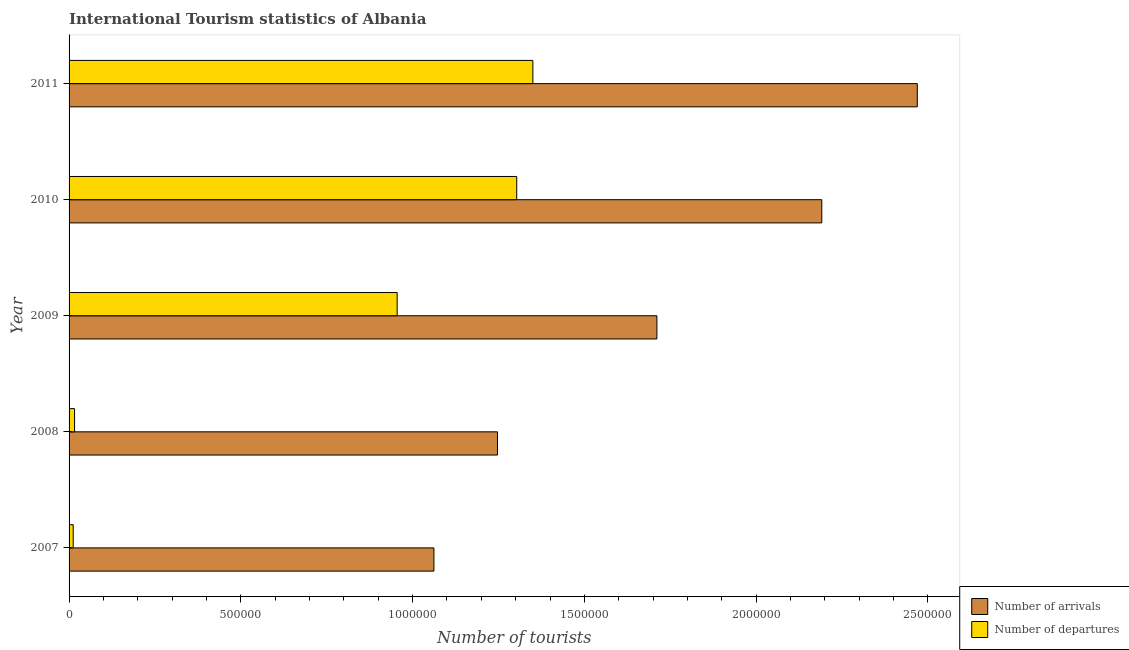How many bars are there on the 5th tick from the top?
Keep it short and to the point. 2. How many bars are there on the 4th tick from the bottom?
Offer a terse response. 2. What is the label of the 5th group of bars from the top?
Your response must be concise. 2007. In how many cases, is the number of bars for a given year not equal to the number of legend labels?
Your answer should be very brief. 0. What is the number of tourist arrivals in 2007?
Ensure brevity in your answer.  1.06e+06. Across all years, what is the maximum number of tourist departures?
Provide a short and direct response. 1.35e+06. Across all years, what is the minimum number of tourist departures?
Offer a very short reply. 1.20e+04. In which year was the number of tourist departures maximum?
Offer a very short reply. 2011. What is the total number of tourist departures in the graph?
Your answer should be compact. 3.64e+06. What is the difference between the number of tourist arrivals in 2009 and that in 2010?
Keep it short and to the point. -4.80e+05. What is the difference between the number of tourist arrivals in 2009 and the number of tourist departures in 2011?
Your answer should be very brief. 3.61e+05. What is the average number of tourist departures per year?
Ensure brevity in your answer.  7.27e+05. In the year 2010, what is the difference between the number of tourist departures and number of tourist arrivals?
Your answer should be very brief. -8.88e+05. What is the ratio of the number of tourist departures in 2009 to that in 2011?
Offer a very short reply. 0.71. Is the number of tourist arrivals in 2008 less than that in 2010?
Provide a succinct answer. Yes. What is the difference between the highest and the second highest number of tourist departures?
Your response must be concise. 4.70e+04. What is the difference between the highest and the lowest number of tourist arrivals?
Ensure brevity in your answer.  1.41e+06. In how many years, is the number of tourist departures greater than the average number of tourist departures taken over all years?
Your answer should be compact. 3. What does the 1st bar from the top in 2011 represents?
Offer a terse response. Number of departures. What does the 1st bar from the bottom in 2009 represents?
Ensure brevity in your answer.  Number of arrivals. How many bars are there?
Offer a very short reply. 10. How many years are there in the graph?
Your response must be concise. 5. What is the difference between two consecutive major ticks on the X-axis?
Make the answer very short. 5.00e+05. Does the graph contain any zero values?
Provide a short and direct response. No. What is the title of the graph?
Your answer should be very brief. International Tourism statistics of Albania. What is the label or title of the X-axis?
Your answer should be compact. Number of tourists. What is the label or title of the Y-axis?
Provide a succinct answer. Year. What is the Number of tourists in Number of arrivals in 2007?
Provide a succinct answer. 1.06e+06. What is the Number of tourists of Number of departures in 2007?
Provide a short and direct response. 1.20e+04. What is the Number of tourists of Number of arrivals in 2008?
Keep it short and to the point. 1.25e+06. What is the Number of tourists of Number of departures in 2008?
Offer a terse response. 1.60e+04. What is the Number of tourists of Number of arrivals in 2009?
Provide a succinct answer. 1.71e+06. What is the Number of tourists of Number of departures in 2009?
Provide a succinct answer. 9.55e+05. What is the Number of tourists in Number of arrivals in 2010?
Provide a succinct answer. 2.19e+06. What is the Number of tourists in Number of departures in 2010?
Keep it short and to the point. 1.30e+06. What is the Number of tourists of Number of arrivals in 2011?
Your answer should be compact. 2.47e+06. What is the Number of tourists of Number of departures in 2011?
Make the answer very short. 1.35e+06. Across all years, what is the maximum Number of tourists in Number of arrivals?
Offer a very short reply. 2.47e+06. Across all years, what is the maximum Number of tourists of Number of departures?
Provide a short and direct response. 1.35e+06. Across all years, what is the minimum Number of tourists in Number of arrivals?
Give a very brief answer. 1.06e+06. Across all years, what is the minimum Number of tourists in Number of departures?
Provide a succinct answer. 1.20e+04. What is the total Number of tourists in Number of arrivals in the graph?
Keep it short and to the point. 8.68e+06. What is the total Number of tourists in Number of departures in the graph?
Make the answer very short. 3.64e+06. What is the difference between the Number of tourists in Number of arrivals in 2007 and that in 2008?
Your answer should be compact. -1.85e+05. What is the difference between the Number of tourists in Number of departures in 2007 and that in 2008?
Offer a very short reply. -4000. What is the difference between the Number of tourists of Number of arrivals in 2007 and that in 2009?
Your answer should be compact. -6.49e+05. What is the difference between the Number of tourists of Number of departures in 2007 and that in 2009?
Provide a succinct answer. -9.43e+05. What is the difference between the Number of tourists of Number of arrivals in 2007 and that in 2010?
Your answer should be compact. -1.13e+06. What is the difference between the Number of tourists in Number of departures in 2007 and that in 2010?
Your answer should be compact. -1.29e+06. What is the difference between the Number of tourists of Number of arrivals in 2007 and that in 2011?
Your answer should be compact. -1.41e+06. What is the difference between the Number of tourists of Number of departures in 2007 and that in 2011?
Provide a succinct answer. -1.34e+06. What is the difference between the Number of tourists of Number of arrivals in 2008 and that in 2009?
Your answer should be very brief. -4.64e+05. What is the difference between the Number of tourists of Number of departures in 2008 and that in 2009?
Make the answer very short. -9.39e+05. What is the difference between the Number of tourists of Number of arrivals in 2008 and that in 2010?
Give a very brief answer. -9.44e+05. What is the difference between the Number of tourists in Number of departures in 2008 and that in 2010?
Offer a very short reply. -1.29e+06. What is the difference between the Number of tourists of Number of arrivals in 2008 and that in 2011?
Your answer should be very brief. -1.22e+06. What is the difference between the Number of tourists in Number of departures in 2008 and that in 2011?
Offer a terse response. -1.33e+06. What is the difference between the Number of tourists of Number of arrivals in 2009 and that in 2010?
Your answer should be very brief. -4.80e+05. What is the difference between the Number of tourists in Number of departures in 2009 and that in 2010?
Offer a very short reply. -3.48e+05. What is the difference between the Number of tourists in Number of arrivals in 2009 and that in 2011?
Make the answer very short. -7.58e+05. What is the difference between the Number of tourists of Number of departures in 2009 and that in 2011?
Give a very brief answer. -3.95e+05. What is the difference between the Number of tourists in Number of arrivals in 2010 and that in 2011?
Your answer should be very brief. -2.78e+05. What is the difference between the Number of tourists of Number of departures in 2010 and that in 2011?
Offer a terse response. -4.70e+04. What is the difference between the Number of tourists of Number of arrivals in 2007 and the Number of tourists of Number of departures in 2008?
Offer a terse response. 1.05e+06. What is the difference between the Number of tourists of Number of arrivals in 2007 and the Number of tourists of Number of departures in 2009?
Your answer should be very brief. 1.07e+05. What is the difference between the Number of tourists in Number of arrivals in 2007 and the Number of tourists in Number of departures in 2010?
Offer a very short reply. -2.41e+05. What is the difference between the Number of tourists of Number of arrivals in 2007 and the Number of tourists of Number of departures in 2011?
Ensure brevity in your answer.  -2.88e+05. What is the difference between the Number of tourists in Number of arrivals in 2008 and the Number of tourists in Number of departures in 2009?
Ensure brevity in your answer.  2.92e+05. What is the difference between the Number of tourists of Number of arrivals in 2008 and the Number of tourists of Number of departures in 2010?
Keep it short and to the point. -5.60e+04. What is the difference between the Number of tourists in Number of arrivals in 2008 and the Number of tourists in Number of departures in 2011?
Give a very brief answer. -1.03e+05. What is the difference between the Number of tourists in Number of arrivals in 2009 and the Number of tourists in Number of departures in 2010?
Your answer should be very brief. 4.08e+05. What is the difference between the Number of tourists in Number of arrivals in 2009 and the Number of tourists in Number of departures in 2011?
Provide a succinct answer. 3.61e+05. What is the difference between the Number of tourists of Number of arrivals in 2010 and the Number of tourists of Number of departures in 2011?
Offer a very short reply. 8.41e+05. What is the average Number of tourists of Number of arrivals per year?
Your answer should be compact. 1.74e+06. What is the average Number of tourists of Number of departures per year?
Your answer should be compact. 7.27e+05. In the year 2007, what is the difference between the Number of tourists in Number of arrivals and Number of tourists in Number of departures?
Keep it short and to the point. 1.05e+06. In the year 2008, what is the difference between the Number of tourists in Number of arrivals and Number of tourists in Number of departures?
Provide a succinct answer. 1.23e+06. In the year 2009, what is the difference between the Number of tourists of Number of arrivals and Number of tourists of Number of departures?
Your answer should be compact. 7.56e+05. In the year 2010, what is the difference between the Number of tourists of Number of arrivals and Number of tourists of Number of departures?
Ensure brevity in your answer.  8.88e+05. In the year 2011, what is the difference between the Number of tourists in Number of arrivals and Number of tourists in Number of departures?
Ensure brevity in your answer.  1.12e+06. What is the ratio of the Number of tourists in Number of arrivals in 2007 to that in 2008?
Your answer should be very brief. 0.85. What is the ratio of the Number of tourists of Number of departures in 2007 to that in 2008?
Ensure brevity in your answer.  0.75. What is the ratio of the Number of tourists of Number of arrivals in 2007 to that in 2009?
Your answer should be compact. 0.62. What is the ratio of the Number of tourists in Number of departures in 2007 to that in 2009?
Your response must be concise. 0.01. What is the ratio of the Number of tourists of Number of arrivals in 2007 to that in 2010?
Ensure brevity in your answer.  0.48. What is the ratio of the Number of tourists of Number of departures in 2007 to that in 2010?
Your answer should be compact. 0.01. What is the ratio of the Number of tourists in Number of arrivals in 2007 to that in 2011?
Offer a terse response. 0.43. What is the ratio of the Number of tourists of Number of departures in 2007 to that in 2011?
Your answer should be very brief. 0.01. What is the ratio of the Number of tourists in Number of arrivals in 2008 to that in 2009?
Provide a short and direct response. 0.73. What is the ratio of the Number of tourists of Number of departures in 2008 to that in 2009?
Your response must be concise. 0.02. What is the ratio of the Number of tourists of Number of arrivals in 2008 to that in 2010?
Provide a succinct answer. 0.57. What is the ratio of the Number of tourists of Number of departures in 2008 to that in 2010?
Make the answer very short. 0.01. What is the ratio of the Number of tourists in Number of arrivals in 2008 to that in 2011?
Provide a short and direct response. 0.51. What is the ratio of the Number of tourists of Number of departures in 2008 to that in 2011?
Your response must be concise. 0.01. What is the ratio of the Number of tourists in Number of arrivals in 2009 to that in 2010?
Keep it short and to the point. 0.78. What is the ratio of the Number of tourists in Number of departures in 2009 to that in 2010?
Your response must be concise. 0.73. What is the ratio of the Number of tourists of Number of arrivals in 2009 to that in 2011?
Keep it short and to the point. 0.69. What is the ratio of the Number of tourists of Number of departures in 2009 to that in 2011?
Give a very brief answer. 0.71. What is the ratio of the Number of tourists in Number of arrivals in 2010 to that in 2011?
Keep it short and to the point. 0.89. What is the ratio of the Number of tourists of Number of departures in 2010 to that in 2011?
Give a very brief answer. 0.97. What is the difference between the highest and the second highest Number of tourists in Number of arrivals?
Offer a terse response. 2.78e+05. What is the difference between the highest and the second highest Number of tourists in Number of departures?
Your answer should be very brief. 4.70e+04. What is the difference between the highest and the lowest Number of tourists in Number of arrivals?
Provide a succinct answer. 1.41e+06. What is the difference between the highest and the lowest Number of tourists in Number of departures?
Provide a short and direct response. 1.34e+06. 